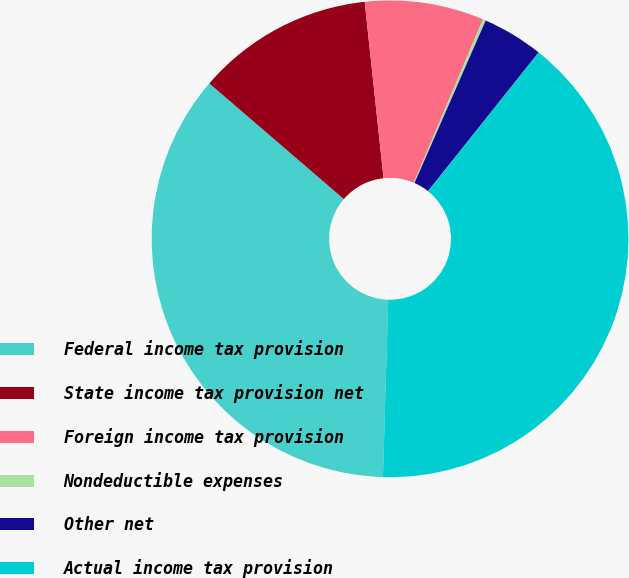Convert chart. <chart><loc_0><loc_0><loc_500><loc_500><pie_chart><fcel>Federal income tax provision<fcel>State income tax provision net<fcel>Foreign income tax provision<fcel>Nondeductible expenses<fcel>Other net<fcel>Actual income tax provision<nl><fcel>35.83%<fcel>12.0%<fcel>8.07%<fcel>0.2%<fcel>4.14%<fcel>39.76%<nl></chart> 